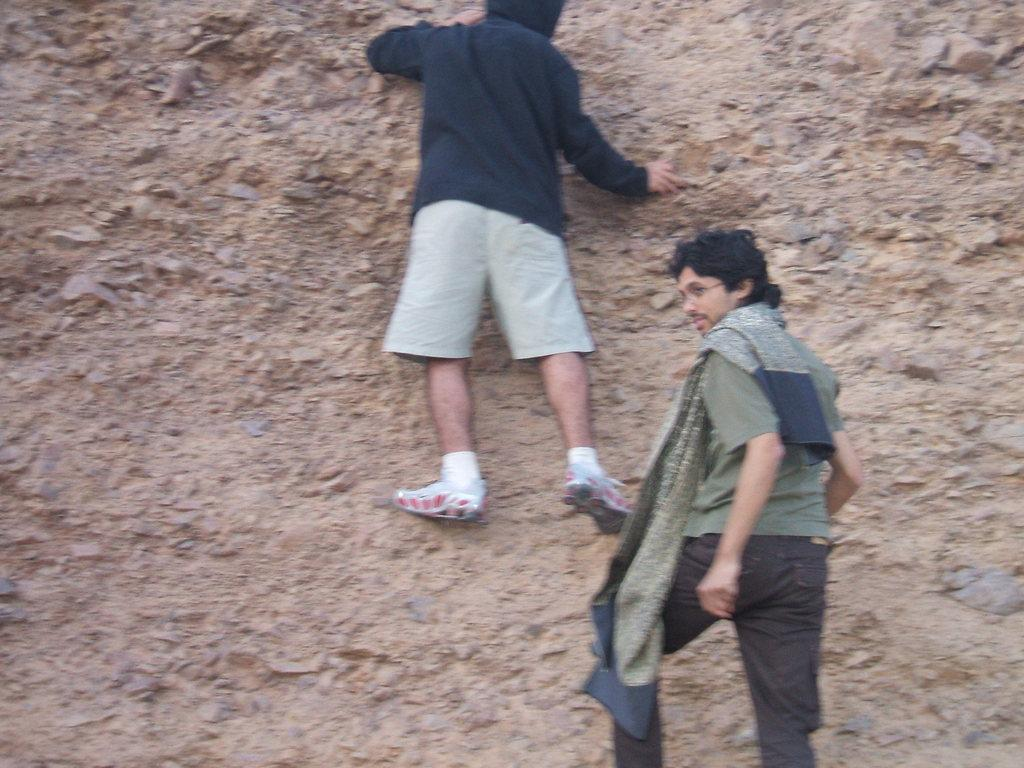How many people are in the image? There are two persons in the image. What are the two persons doing in the image? The two persons are trekking. What type of liquid can be seen dripping from the foot of the person in the image? There is no liquid or foot visible in the image; the two persons are trekking, but no specific body parts or substances are mentioned in the provided facts. 